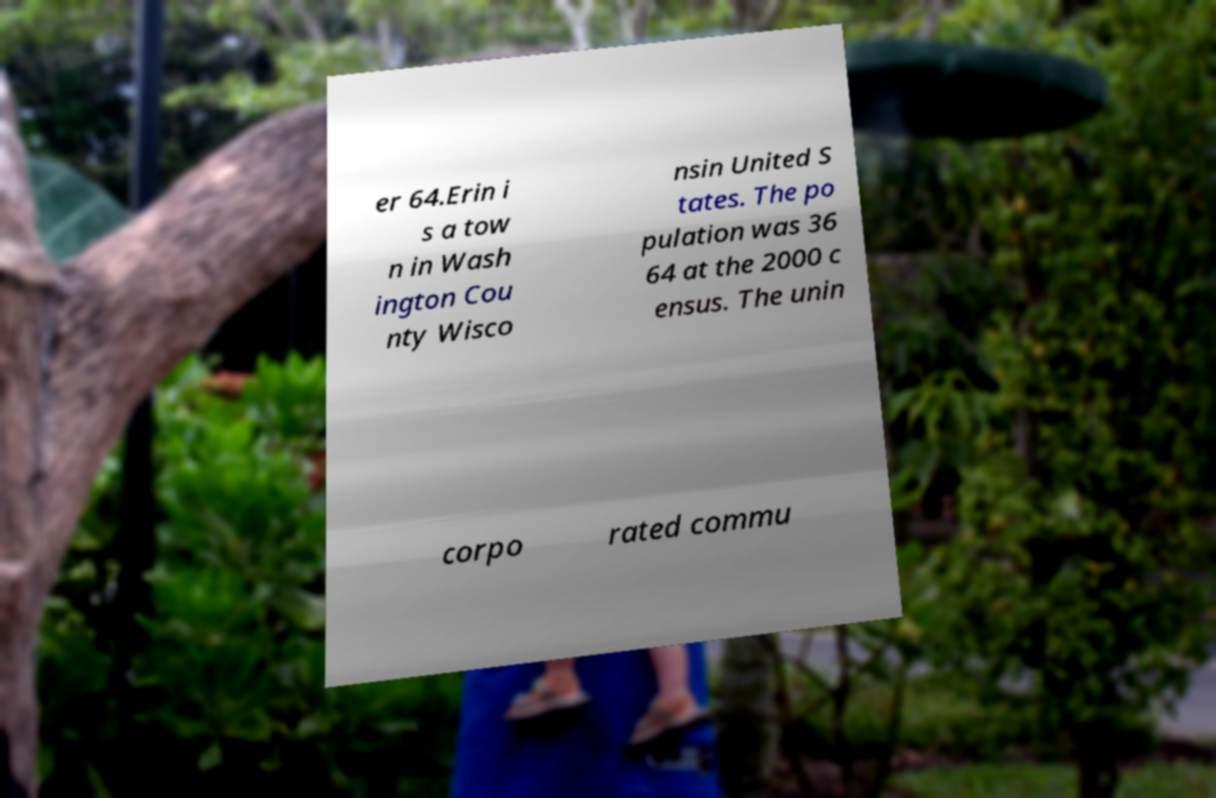Could you assist in decoding the text presented in this image and type it out clearly? er 64.Erin i s a tow n in Wash ington Cou nty Wisco nsin United S tates. The po pulation was 36 64 at the 2000 c ensus. The unin corpo rated commu 